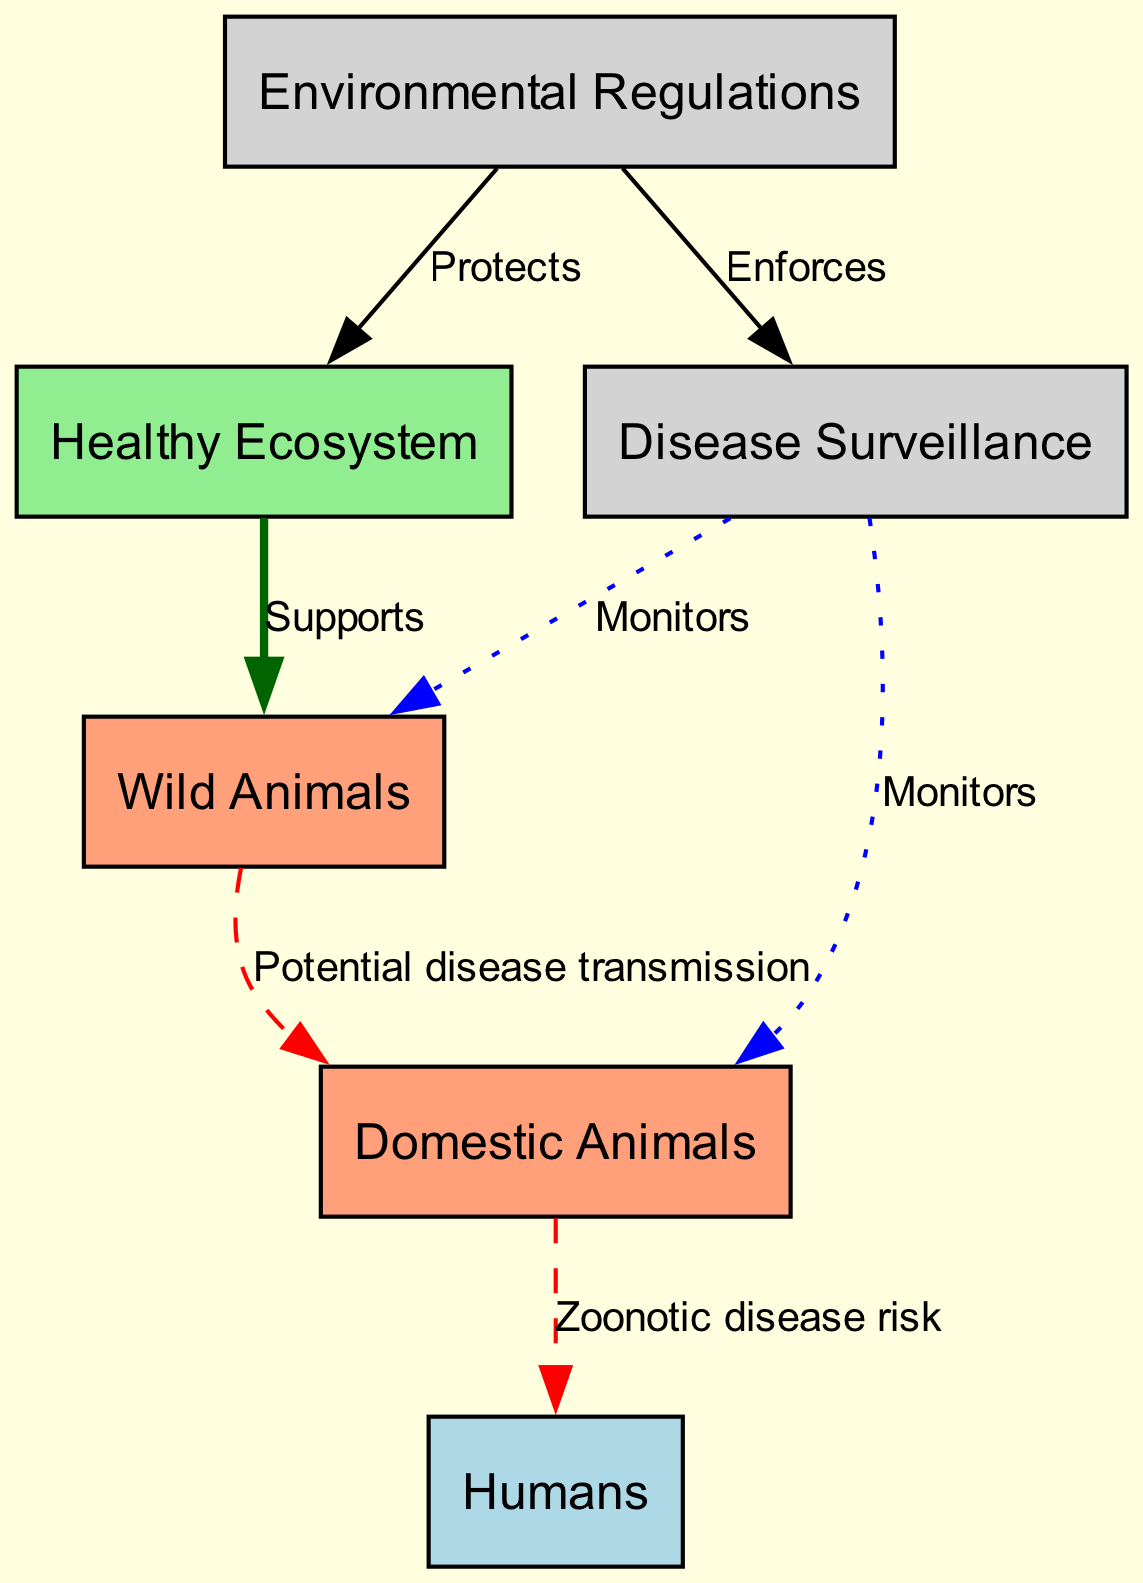What is the role of a Healthy Ecosystem? The Healthy Ecosystem node is connected to the Wild Animals node with an edge labeled "Supports," indicating that it provides a foundation for wildlife.
Answer: Supports How many nodes are present in the diagram? The diagram contains six nodes: Healthy Ecosystem, Wild Animals, Domestic Animals, Humans, Environmental Regulations, and Disease Surveillance.
Answer: 6 What color represents Domestic Animals in the diagram? The Domestic Animals node is shown in lightsalmon color, which distinguishes it from the other node types.
Answer: Lightsalmon Which node is monitored by Disease Surveillance? Both the Wild Animals node and the Domestic Animals node have edges labeled "Monitors" connecting to them from the Disease Surveillance node, indicating it oversees these groups.
Answer: Wild Animals, Domestic Animals What is the relationship between Domestic Animals and Humans in the food chain? The edge from Domestic Animals to Humans is labeled "Zoonotic disease risk," indicating a potential health threat that can be transmitted from animals to humans.
Answer: Zoonotic disease risk How do Environmental Regulations impact the Healthy Ecosystem? The Environmental Regulations node connects to the Healthy Ecosystem node with an edge labeled "Protects," showing that regulations are in place to maintain ecosystem health.
Answer: Protects What is the effect of Environmental Regulations on Disease Surveillance? Environmental Regulations connects to Disease Surveillance with an edge labeled "Enforces," indicating that regulations help support the monitoring of diseases.
Answer: Enforces What can be concluded about the link between Wild Animals and Domestic Animals? The edge labeled "Potential disease transmission" from Wild Animals to Domestic Animals shows that diseases can move from wildlife to domesticated species, highlighting an ecological risk.
Answer: Potential disease transmission Which color represents the Humans node in the diagram? The Humans node is filled in lightblue color, differentiating it visually from other nodes in the diagram.
Answer: Lightblue 